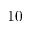<formula> <loc_0><loc_0><loc_500><loc_500>1 0</formula> 